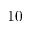<formula> <loc_0><loc_0><loc_500><loc_500>1 0</formula> 